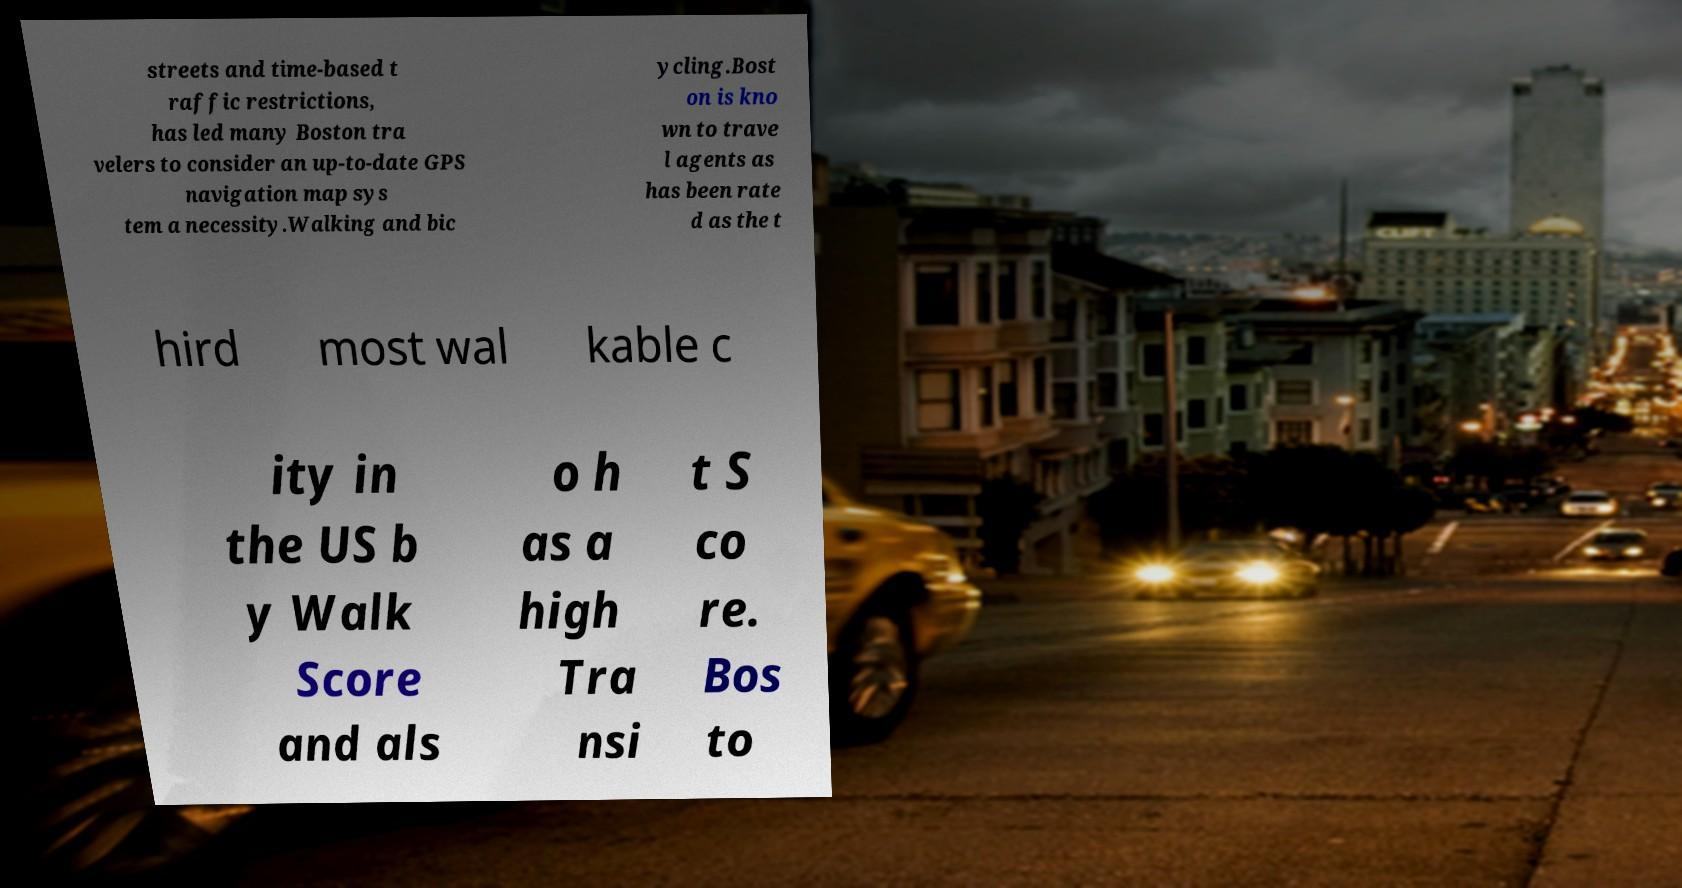For documentation purposes, I need the text within this image transcribed. Could you provide that? streets and time-based t raffic restrictions, has led many Boston tra velers to consider an up-to-date GPS navigation map sys tem a necessity.Walking and bic ycling.Bost on is kno wn to trave l agents as has been rate d as the t hird most wal kable c ity in the US b y Walk Score and als o h as a high Tra nsi t S co re. Bos to 